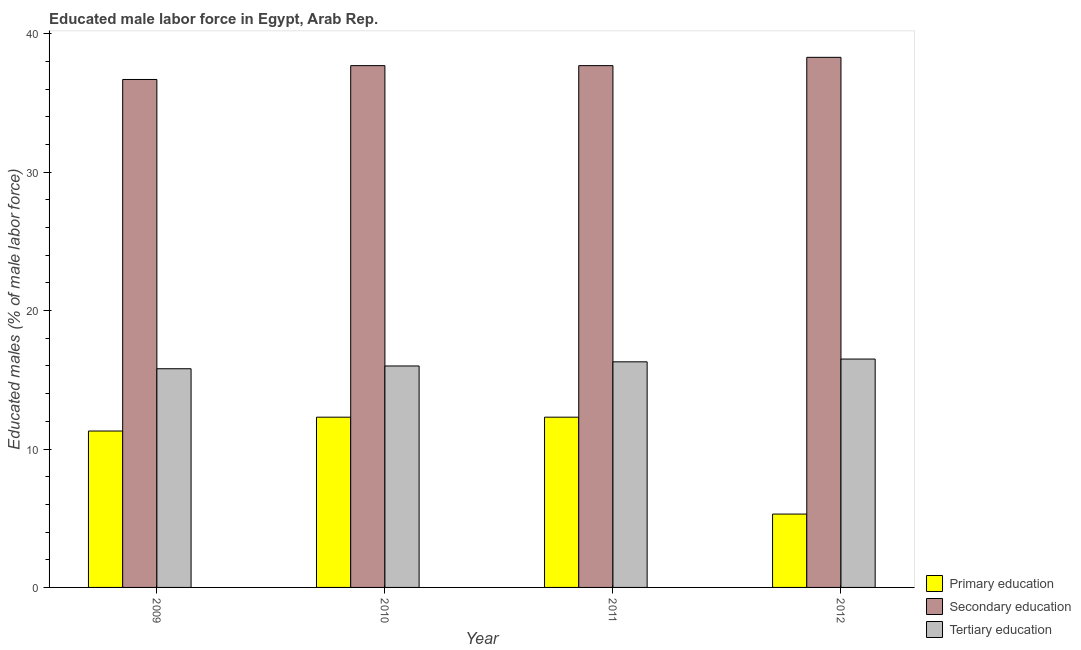How many different coloured bars are there?
Offer a very short reply. 3. How many groups of bars are there?
Give a very brief answer. 4. How many bars are there on the 4th tick from the right?
Your response must be concise. 3. In how many cases, is the number of bars for a given year not equal to the number of legend labels?
Your answer should be very brief. 0. What is the percentage of male labor force who received secondary education in 2011?
Offer a very short reply. 37.7. Across all years, what is the maximum percentage of male labor force who received primary education?
Your response must be concise. 12.3. Across all years, what is the minimum percentage of male labor force who received primary education?
Ensure brevity in your answer.  5.3. What is the total percentage of male labor force who received tertiary education in the graph?
Offer a very short reply. 64.6. What is the difference between the percentage of male labor force who received tertiary education in 2011 and the percentage of male labor force who received secondary education in 2009?
Provide a short and direct response. 0.5. What is the average percentage of male labor force who received primary education per year?
Make the answer very short. 10.3. In the year 2009, what is the difference between the percentage of male labor force who received primary education and percentage of male labor force who received tertiary education?
Make the answer very short. 0. What is the ratio of the percentage of male labor force who received secondary education in 2011 to that in 2012?
Keep it short and to the point. 0.98. What is the difference between the highest and the lowest percentage of male labor force who received secondary education?
Your response must be concise. 1.6. Is the sum of the percentage of male labor force who received secondary education in 2009 and 2011 greater than the maximum percentage of male labor force who received primary education across all years?
Your answer should be very brief. Yes. What does the 2nd bar from the left in 2012 represents?
Provide a succinct answer. Secondary education. What does the 1st bar from the right in 2011 represents?
Provide a succinct answer. Tertiary education. Is it the case that in every year, the sum of the percentage of male labor force who received primary education and percentage of male labor force who received secondary education is greater than the percentage of male labor force who received tertiary education?
Keep it short and to the point. Yes. How many bars are there?
Offer a very short reply. 12. How are the legend labels stacked?
Your answer should be very brief. Vertical. What is the title of the graph?
Provide a short and direct response. Educated male labor force in Egypt, Arab Rep. Does "Tertiary" appear as one of the legend labels in the graph?
Your answer should be very brief. No. What is the label or title of the Y-axis?
Make the answer very short. Educated males (% of male labor force). What is the Educated males (% of male labor force) in Primary education in 2009?
Offer a very short reply. 11.3. What is the Educated males (% of male labor force) in Secondary education in 2009?
Your answer should be very brief. 36.7. What is the Educated males (% of male labor force) of Tertiary education in 2009?
Make the answer very short. 15.8. What is the Educated males (% of male labor force) of Primary education in 2010?
Ensure brevity in your answer.  12.3. What is the Educated males (% of male labor force) in Secondary education in 2010?
Ensure brevity in your answer.  37.7. What is the Educated males (% of male labor force) in Primary education in 2011?
Ensure brevity in your answer.  12.3. What is the Educated males (% of male labor force) in Secondary education in 2011?
Provide a short and direct response. 37.7. What is the Educated males (% of male labor force) of Tertiary education in 2011?
Make the answer very short. 16.3. What is the Educated males (% of male labor force) in Primary education in 2012?
Make the answer very short. 5.3. What is the Educated males (% of male labor force) of Secondary education in 2012?
Ensure brevity in your answer.  38.3. Across all years, what is the maximum Educated males (% of male labor force) in Primary education?
Offer a very short reply. 12.3. Across all years, what is the maximum Educated males (% of male labor force) of Secondary education?
Provide a short and direct response. 38.3. Across all years, what is the minimum Educated males (% of male labor force) of Primary education?
Ensure brevity in your answer.  5.3. Across all years, what is the minimum Educated males (% of male labor force) in Secondary education?
Give a very brief answer. 36.7. Across all years, what is the minimum Educated males (% of male labor force) in Tertiary education?
Provide a succinct answer. 15.8. What is the total Educated males (% of male labor force) of Primary education in the graph?
Your answer should be compact. 41.2. What is the total Educated males (% of male labor force) of Secondary education in the graph?
Provide a short and direct response. 150.4. What is the total Educated males (% of male labor force) of Tertiary education in the graph?
Offer a terse response. 64.6. What is the difference between the Educated males (% of male labor force) in Primary education in 2009 and that in 2010?
Give a very brief answer. -1. What is the difference between the Educated males (% of male labor force) in Primary education in 2009 and that in 2011?
Offer a terse response. -1. What is the difference between the Educated males (% of male labor force) in Secondary education in 2009 and that in 2011?
Give a very brief answer. -1. What is the difference between the Educated males (% of male labor force) in Primary education in 2009 and that in 2012?
Provide a short and direct response. 6. What is the difference between the Educated males (% of male labor force) in Secondary education in 2009 and that in 2012?
Ensure brevity in your answer.  -1.6. What is the difference between the Educated males (% of male labor force) of Tertiary education in 2009 and that in 2012?
Give a very brief answer. -0.7. What is the difference between the Educated males (% of male labor force) in Primary education in 2010 and that in 2011?
Ensure brevity in your answer.  0. What is the difference between the Educated males (% of male labor force) in Tertiary education in 2010 and that in 2011?
Provide a succinct answer. -0.3. What is the difference between the Educated males (% of male labor force) of Secondary education in 2010 and that in 2012?
Your response must be concise. -0.6. What is the difference between the Educated males (% of male labor force) of Primary education in 2011 and that in 2012?
Your answer should be very brief. 7. What is the difference between the Educated males (% of male labor force) in Secondary education in 2011 and that in 2012?
Your answer should be compact. -0.6. What is the difference between the Educated males (% of male labor force) in Primary education in 2009 and the Educated males (% of male labor force) in Secondary education in 2010?
Your answer should be compact. -26.4. What is the difference between the Educated males (% of male labor force) of Secondary education in 2009 and the Educated males (% of male labor force) of Tertiary education in 2010?
Your answer should be very brief. 20.7. What is the difference between the Educated males (% of male labor force) in Primary education in 2009 and the Educated males (% of male labor force) in Secondary education in 2011?
Your answer should be very brief. -26.4. What is the difference between the Educated males (% of male labor force) in Secondary education in 2009 and the Educated males (% of male labor force) in Tertiary education in 2011?
Ensure brevity in your answer.  20.4. What is the difference between the Educated males (% of male labor force) of Primary education in 2009 and the Educated males (% of male labor force) of Secondary education in 2012?
Offer a terse response. -27. What is the difference between the Educated males (% of male labor force) in Secondary education in 2009 and the Educated males (% of male labor force) in Tertiary education in 2012?
Make the answer very short. 20.2. What is the difference between the Educated males (% of male labor force) in Primary education in 2010 and the Educated males (% of male labor force) in Secondary education in 2011?
Your response must be concise. -25.4. What is the difference between the Educated males (% of male labor force) in Secondary education in 2010 and the Educated males (% of male labor force) in Tertiary education in 2011?
Offer a terse response. 21.4. What is the difference between the Educated males (% of male labor force) in Secondary education in 2010 and the Educated males (% of male labor force) in Tertiary education in 2012?
Provide a succinct answer. 21.2. What is the difference between the Educated males (% of male labor force) in Primary education in 2011 and the Educated males (% of male labor force) in Secondary education in 2012?
Your answer should be compact. -26. What is the difference between the Educated males (% of male labor force) of Primary education in 2011 and the Educated males (% of male labor force) of Tertiary education in 2012?
Provide a succinct answer. -4.2. What is the difference between the Educated males (% of male labor force) of Secondary education in 2011 and the Educated males (% of male labor force) of Tertiary education in 2012?
Your response must be concise. 21.2. What is the average Educated males (% of male labor force) of Primary education per year?
Provide a short and direct response. 10.3. What is the average Educated males (% of male labor force) of Secondary education per year?
Make the answer very short. 37.6. What is the average Educated males (% of male labor force) in Tertiary education per year?
Your answer should be compact. 16.15. In the year 2009, what is the difference between the Educated males (% of male labor force) of Primary education and Educated males (% of male labor force) of Secondary education?
Your answer should be compact. -25.4. In the year 2009, what is the difference between the Educated males (% of male labor force) of Primary education and Educated males (% of male labor force) of Tertiary education?
Keep it short and to the point. -4.5. In the year 2009, what is the difference between the Educated males (% of male labor force) in Secondary education and Educated males (% of male labor force) in Tertiary education?
Your answer should be very brief. 20.9. In the year 2010, what is the difference between the Educated males (% of male labor force) of Primary education and Educated males (% of male labor force) of Secondary education?
Give a very brief answer. -25.4. In the year 2010, what is the difference between the Educated males (% of male labor force) of Primary education and Educated males (% of male labor force) of Tertiary education?
Offer a terse response. -3.7. In the year 2010, what is the difference between the Educated males (% of male labor force) of Secondary education and Educated males (% of male labor force) of Tertiary education?
Offer a terse response. 21.7. In the year 2011, what is the difference between the Educated males (% of male labor force) in Primary education and Educated males (% of male labor force) in Secondary education?
Offer a very short reply. -25.4. In the year 2011, what is the difference between the Educated males (% of male labor force) of Secondary education and Educated males (% of male labor force) of Tertiary education?
Offer a terse response. 21.4. In the year 2012, what is the difference between the Educated males (% of male labor force) in Primary education and Educated males (% of male labor force) in Secondary education?
Keep it short and to the point. -33. In the year 2012, what is the difference between the Educated males (% of male labor force) of Secondary education and Educated males (% of male labor force) of Tertiary education?
Offer a terse response. 21.8. What is the ratio of the Educated males (% of male labor force) of Primary education in 2009 to that in 2010?
Ensure brevity in your answer.  0.92. What is the ratio of the Educated males (% of male labor force) of Secondary education in 2009 to that in 2010?
Keep it short and to the point. 0.97. What is the ratio of the Educated males (% of male labor force) of Tertiary education in 2009 to that in 2010?
Provide a short and direct response. 0.99. What is the ratio of the Educated males (% of male labor force) in Primary education in 2009 to that in 2011?
Keep it short and to the point. 0.92. What is the ratio of the Educated males (% of male labor force) of Secondary education in 2009 to that in 2011?
Make the answer very short. 0.97. What is the ratio of the Educated males (% of male labor force) of Tertiary education in 2009 to that in 2011?
Your answer should be compact. 0.97. What is the ratio of the Educated males (% of male labor force) of Primary education in 2009 to that in 2012?
Provide a succinct answer. 2.13. What is the ratio of the Educated males (% of male labor force) in Secondary education in 2009 to that in 2012?
Your answer should be compact. 0.96. What is the ratio of the Educated males (% of male labor force) in Tertiary education in 2009 to that in 2012?
Offer a terse response. 0.96. What is the ratio of the Educated males (% of male labor force) in Primary education in 2010 to that in 2011?
Ensure brevity in your answer.  1. What is the ratio of the Educated males (% of male labor force) of Secondary education in 2010 to that in 2011?
Your response must be concise. 1. What is the ratio of the Educated males (% of male labor force) of Tertiary education in 2010 to that in 2011?
Provide a succinct answer. 0.98. What is the ratio of the Educated males (% of male labor force) of Primary education in 2010 to that in 2012?
Your response must be concise. 2.32. What is the ratio of the Educated males (% of male labor force) of Secondary education in 2010 to that in 2012?
Provide a succinct answer. 0.98. What is the ratio of the Educated males (% of male labor force) of Tertiary education in 2010 to that in 2012?
Offer a very short reply. 0.97. What is the ratio of the Educated males (% of male labor force) in Primary education in 2011 to that in 2012?
Give a very brief answer. 2.32. What is the ratio of the Educated males (% of male labor force) in Secondary education in 2011 to that in 2012?
Give a very brief answer. 0.98. What is the ratio of the Educated males (% of male labor force) of Tertiary education in 2011 to that in 2012?
Give a very brief answer. 0.99. What is the difference between the highest and the second highest Educated males (% of male labor force) of Primary education?
Offer a very short reply. 0. What is the difference between the highest and the second highest Educated males (% of male labor force) of Tertiary education?
Provide a short and direct response. 0.2. What is the difference between the highest and the lowest Educated males (% of male labor force) in Primary education?
Your response must be concise. 7. 